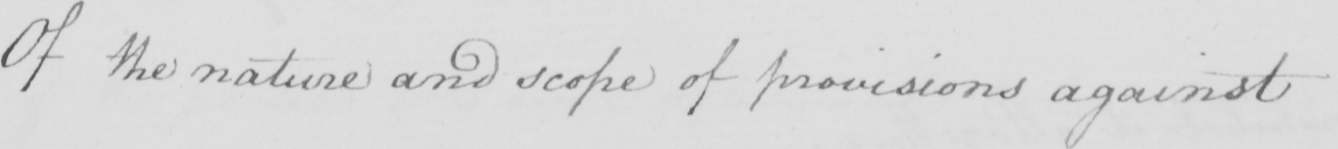What does this handwritten line say? Of the nature and scope of provisions against 